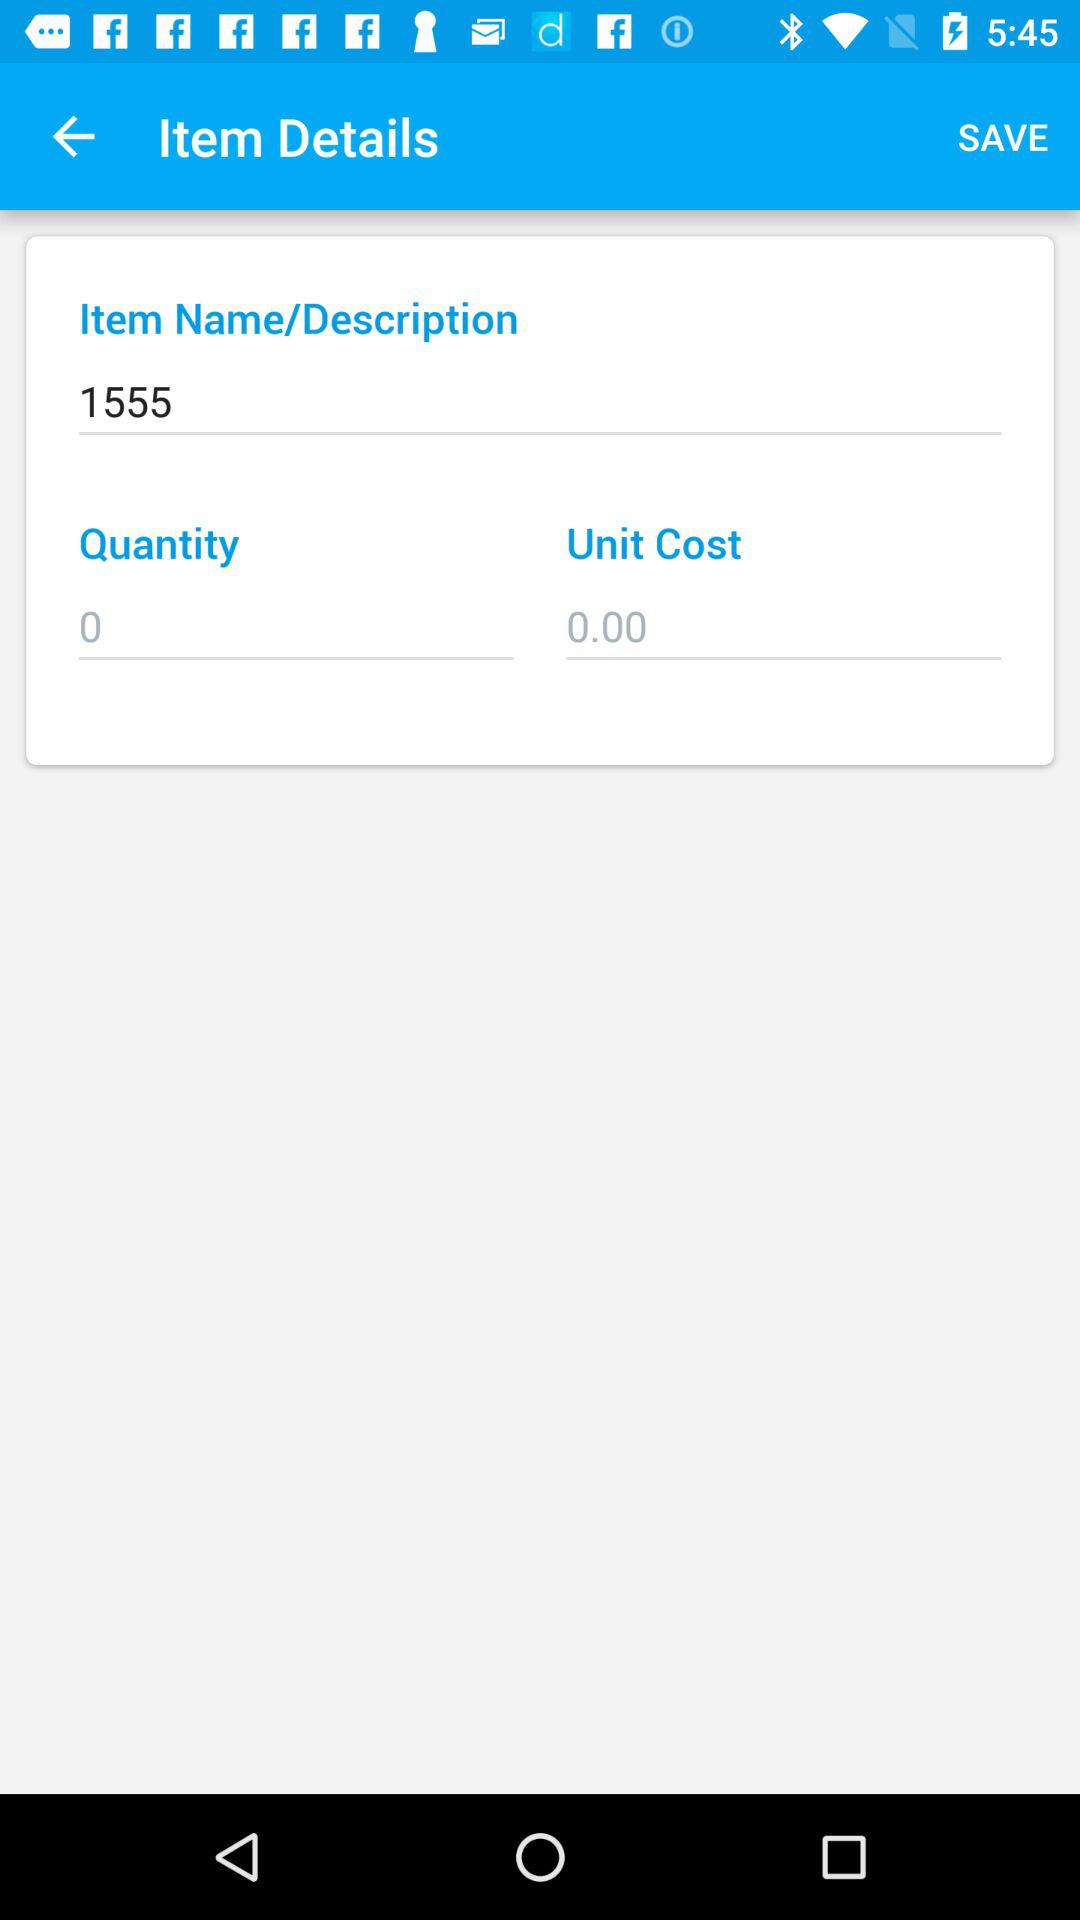What is the quantity? The quantity is 0. 